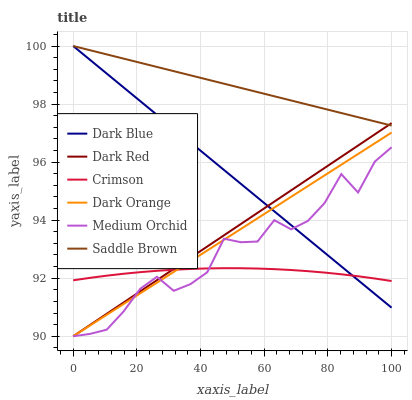Does Crimson have the minimum area under the curve?
Answer yes or no. Yes. Does Saddle Brown have the maximum area under the curve?
Answer yes or no. Yes. Does Dark Red have the minimum area under the curve?
Answer yes or no. No. Does Dark Red have the maximum area under the curve?
Answer yes or no. No. Is Saddle Brown the smoothest?
Answer yes or no. Yes. Is Medium Orchid the roughest?
Answer yes or no. Yes. Is Dark Red the smoothest?
Answer yes or no. No. Is Dark Red the roughest?
Answer yes or no. No. Does Dark Orange have the lowest value?
Answer yes or no. Yes. Does Dark Blue have the lowest value?
Answer yes or no. No. Does Saddle Brown have the highest value?
Answer yes or no. Yes. Does Dark Red have the highest value?
Answer yes or no. No. Is Crimson less than Saddle Brown?
Answer yes or no. Yes. Is Saddle Brown greater than Dark Orange?
Answer yes or no. Yes. Does Medium Orchid intersect Dark Orange?
Answer yes or no. Yes. Is Medium Orchid less than Dark Orange?
Answer yes or no. No. Is Medium Orchid greater than Dark Orange?
Answer yes or no. No. Does Crimson intersect Saddle Brown?
Answer yes or no. No. 